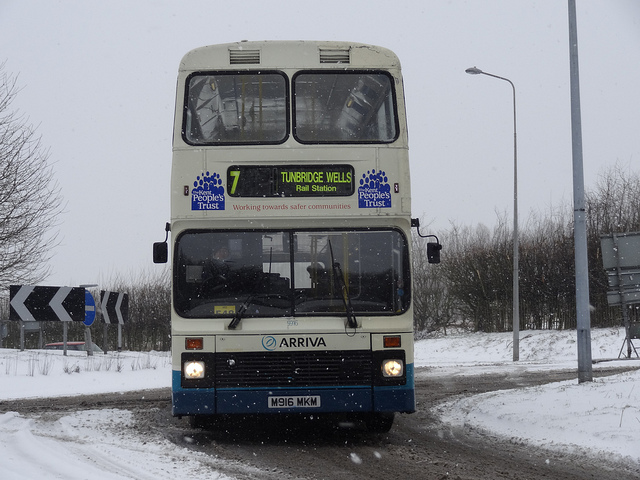Extract all visible text content from this image. People's 7 TUNBRIDGE WELLS Rail Station People's Trust MKM M9I6 ARRIVA Trust 